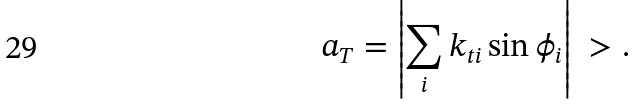<formula> <loc_0><loc_0><loc_500><loc_500>a _ { T } = \left | \sum _ { i } k _ { t i } \sin \phi _ { i } \right | \ > .</formula> 